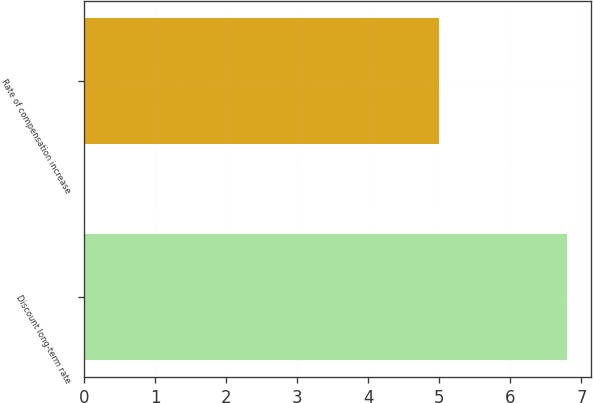Convert chart. <chart><loc_0><loc_0><loc_500><loc_500><bar_chart><fcel>Discount long-term rate<fcel>Rate of compensation increase<nl><fcel>6.8<fcel>5<nl></chart> 